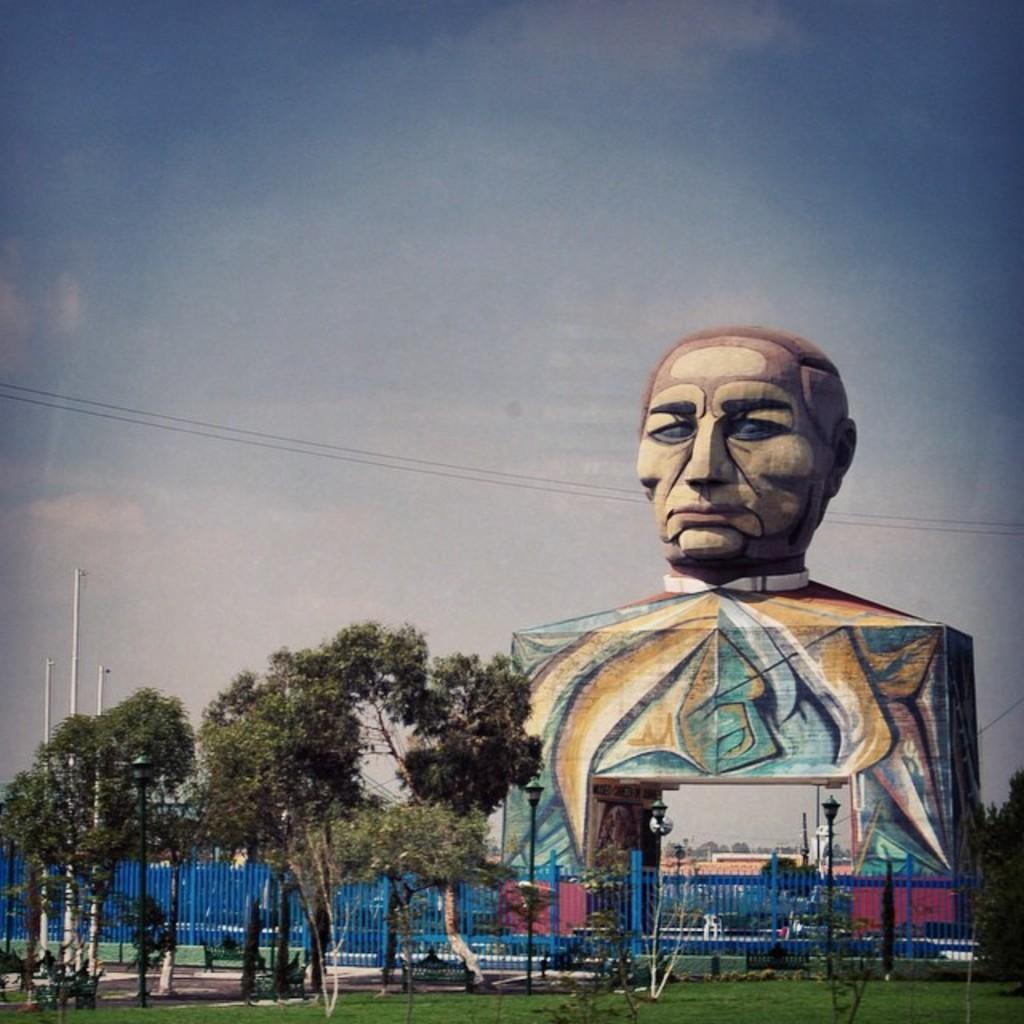Can you describe this image briefly? In this image we can see a statue with some painting on it. We can also see some street lamps, a fence, grass, a group of trees, poles, wires and the sky which looks cloudy. 